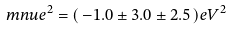<formula> <loc_0><loc_0><loc_500><loc_500>\ m n u e ^ { 2 } = ( \, - 1 . 0 \pm 3 . 0 \pm 2 . 5 \, ) e V ^ { 2 }</formula> 